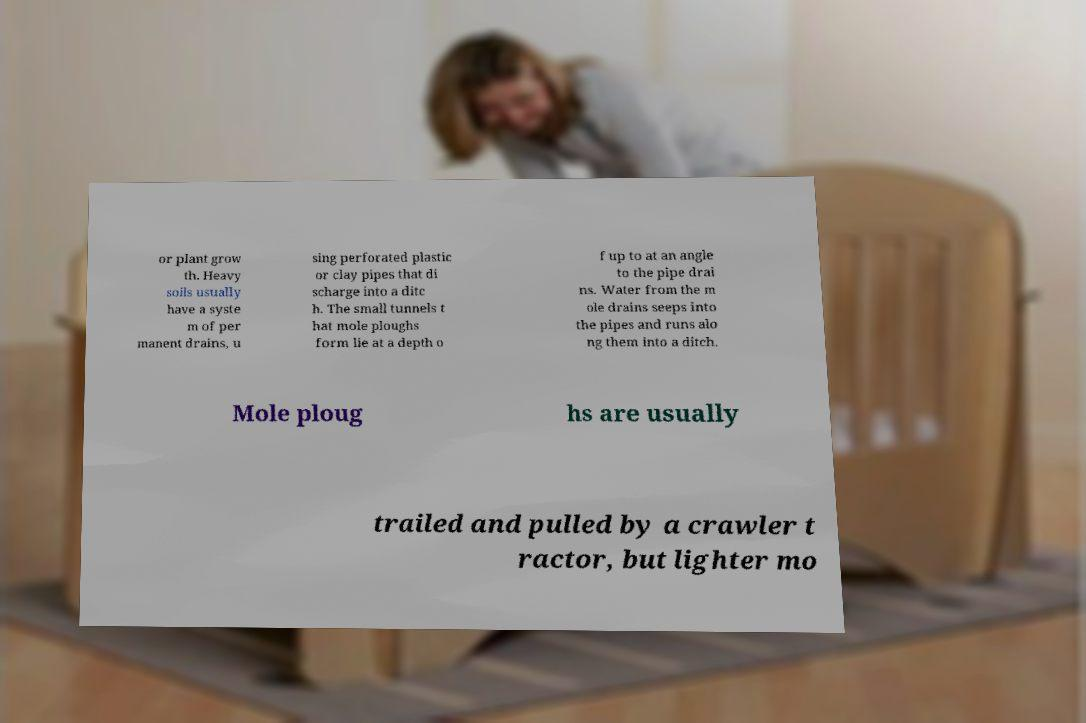For documentation purposes, I need the text within this image transcribed. Could you provide that? or plant grow th. Heavy soils usually have a syste m of per manent drains, u sing perforated plastic or clay pipes that di scharge into a ditc h. The small tunnels t hat mole ploughs form lie at a depth o f up to at an angle to the pipe drai ns. Water from the m ole drains seeps into the pipes and runs alo ng them into a ditch. Mole ploug hs are usually trailed and pulled by a crawler t ractor, but lighter mo 